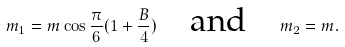Convert formula to latex. <formula><loc_0><loc_0><loc_500><loc_500>m _ { 1 } = m \cos \frac { \pi } { 6 } ( 1 + \frac { B } { 4 } ) \quad \text {and\quad } m _ { 2 } = m .</formula> 